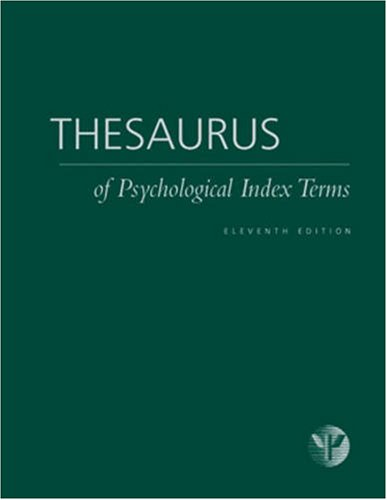Is this book related to Reference? Yes, indeed, it is a reference book, ideal for those looking to familiarize themselves with or clarify psychological terms and concepts. 